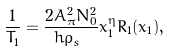<formula> <loc_0><loc_0><loc_500><loc_500>\frac { 1 } { T _ { 1 } } = \frac { 2 A _ { \pi } ^ { 2 } N _ { 0 } ^ { 2 } } { \hbar { \rho } _ { s } } x _ { 1 } ^ { \eta } R _ { 1 } ( x _ { 1 } ) ,</formula> 